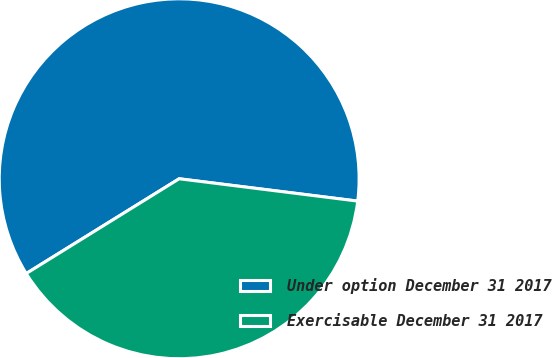Convert chart to OTSL. <chart><loc_0><loc_0><loc_500><loc_500><pie_chart><fcel>Under option December 31 2017<fcel>Exercisable December 31 2017<nl><fcel>60.81%<fcel>39.19%<nl></chart> 